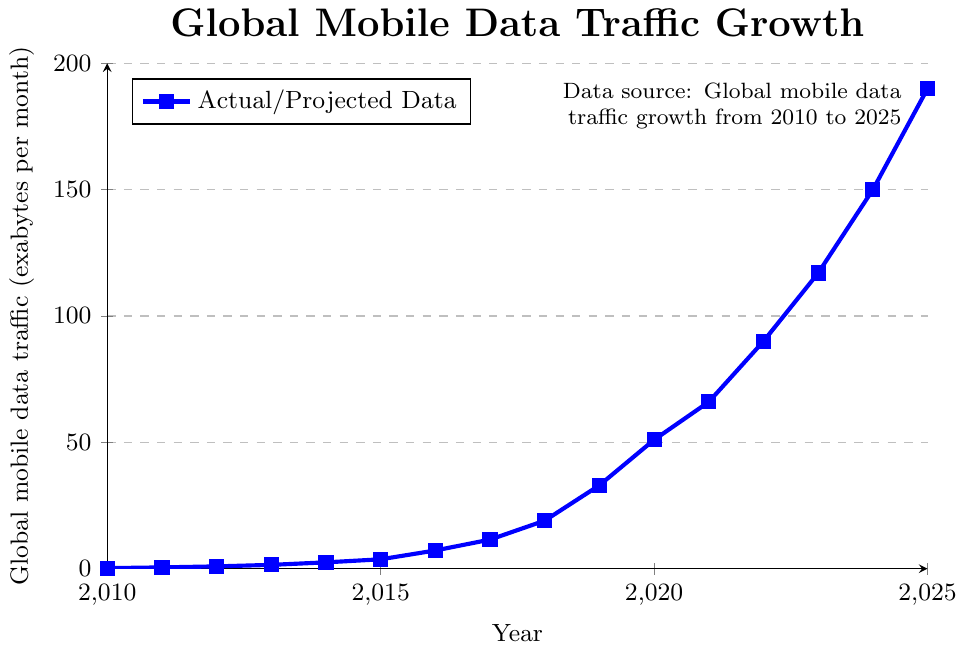What was the global mobile data traffic in 2017? The chart shows the global mobile data traffic values for different years. For 2017, the value can be directly read from the chart.
Answer: 11.5 exabytes per month How much did the global mobile data traffic increase from 2010 to 2011? To find this, subtract the 2010 value from the 2011 value: 0.5 - 0.2.
Answer: 0.3 exabytes per month During which year did global mobile data traffic first exceed 10 exabytes per month? Scan the chart to find the first instance where the y-value surpasses 10 exabytes per month.
Answer: 2017 By how much did the global mobile data traffic increase between 2010 and 2020? Calculate the difference between the values for 2020 and 2010: 51.0 - 0.2.
Answer: 50.8 exabytes per month Which year saw the highest single-year increase in global mobile data traffic? Calculate the year-over-year increases, then identify the maximum. E.g., for 2011-2012, the increase is 0.9 - 0.5 = 0.4, and so on. The largest increase is between 2018 and 2019: 33.0 - 19.0 = 14.0.
Answer: 2019 Between 2010 and 2025, what is the approximate average annual increase in global mobile data traffic? (Traffic in 2025 - Traffic in 2010) / (2025 - 2010). So, (190.0 - 0.2) / 15.
Answer: 12.66 exabytes per month Compare the global mobile data traffic in 2015 with 2019. Which year had more traffic, and by how much? The traffic values for 2015 and 2019 are 3.7 and 33.0, respectively. Subtracting the smaller from the larger value shows the difference.
Answer: 2019 had more traffic by 29.3 exabytes per month Which is greater: the increase in global mobile data traffic from 2013 to 2014 or from 2014 to 2015? Calculate the increases: 2013 to 2014: 2.5-1.5 = 1.0; 2014 to 2015: 3.7-2.5 = 1.2. Comparing these, the latter is greater.
Answer: 2014 to 2015 is greater by 0.2 exabytes per month What is the median value of global mobile data traffic from 2010 to 2025? Arrange the values in numerical order and find the middle value. The data points are: [0.2, 0.5, 0.9, 1.5, 2.5, 3.7, 7.2, 11.5, 19.0, 33.0, 51.0, 66.0, 90.0, 117.0, 150.0, 190.0]. The median is the average of the 8th and 9th values: (11.5 + 19.0) / 2.
Answer: 15.25 exabytes per month How does the color used for the plot lines help in interpreting the data? The plots are drawn using a single color (blue) with square markers. This consistent color helps easily identify the data points and follow the trend over the years.
Answer: Blue color and square markers help in easy identification 